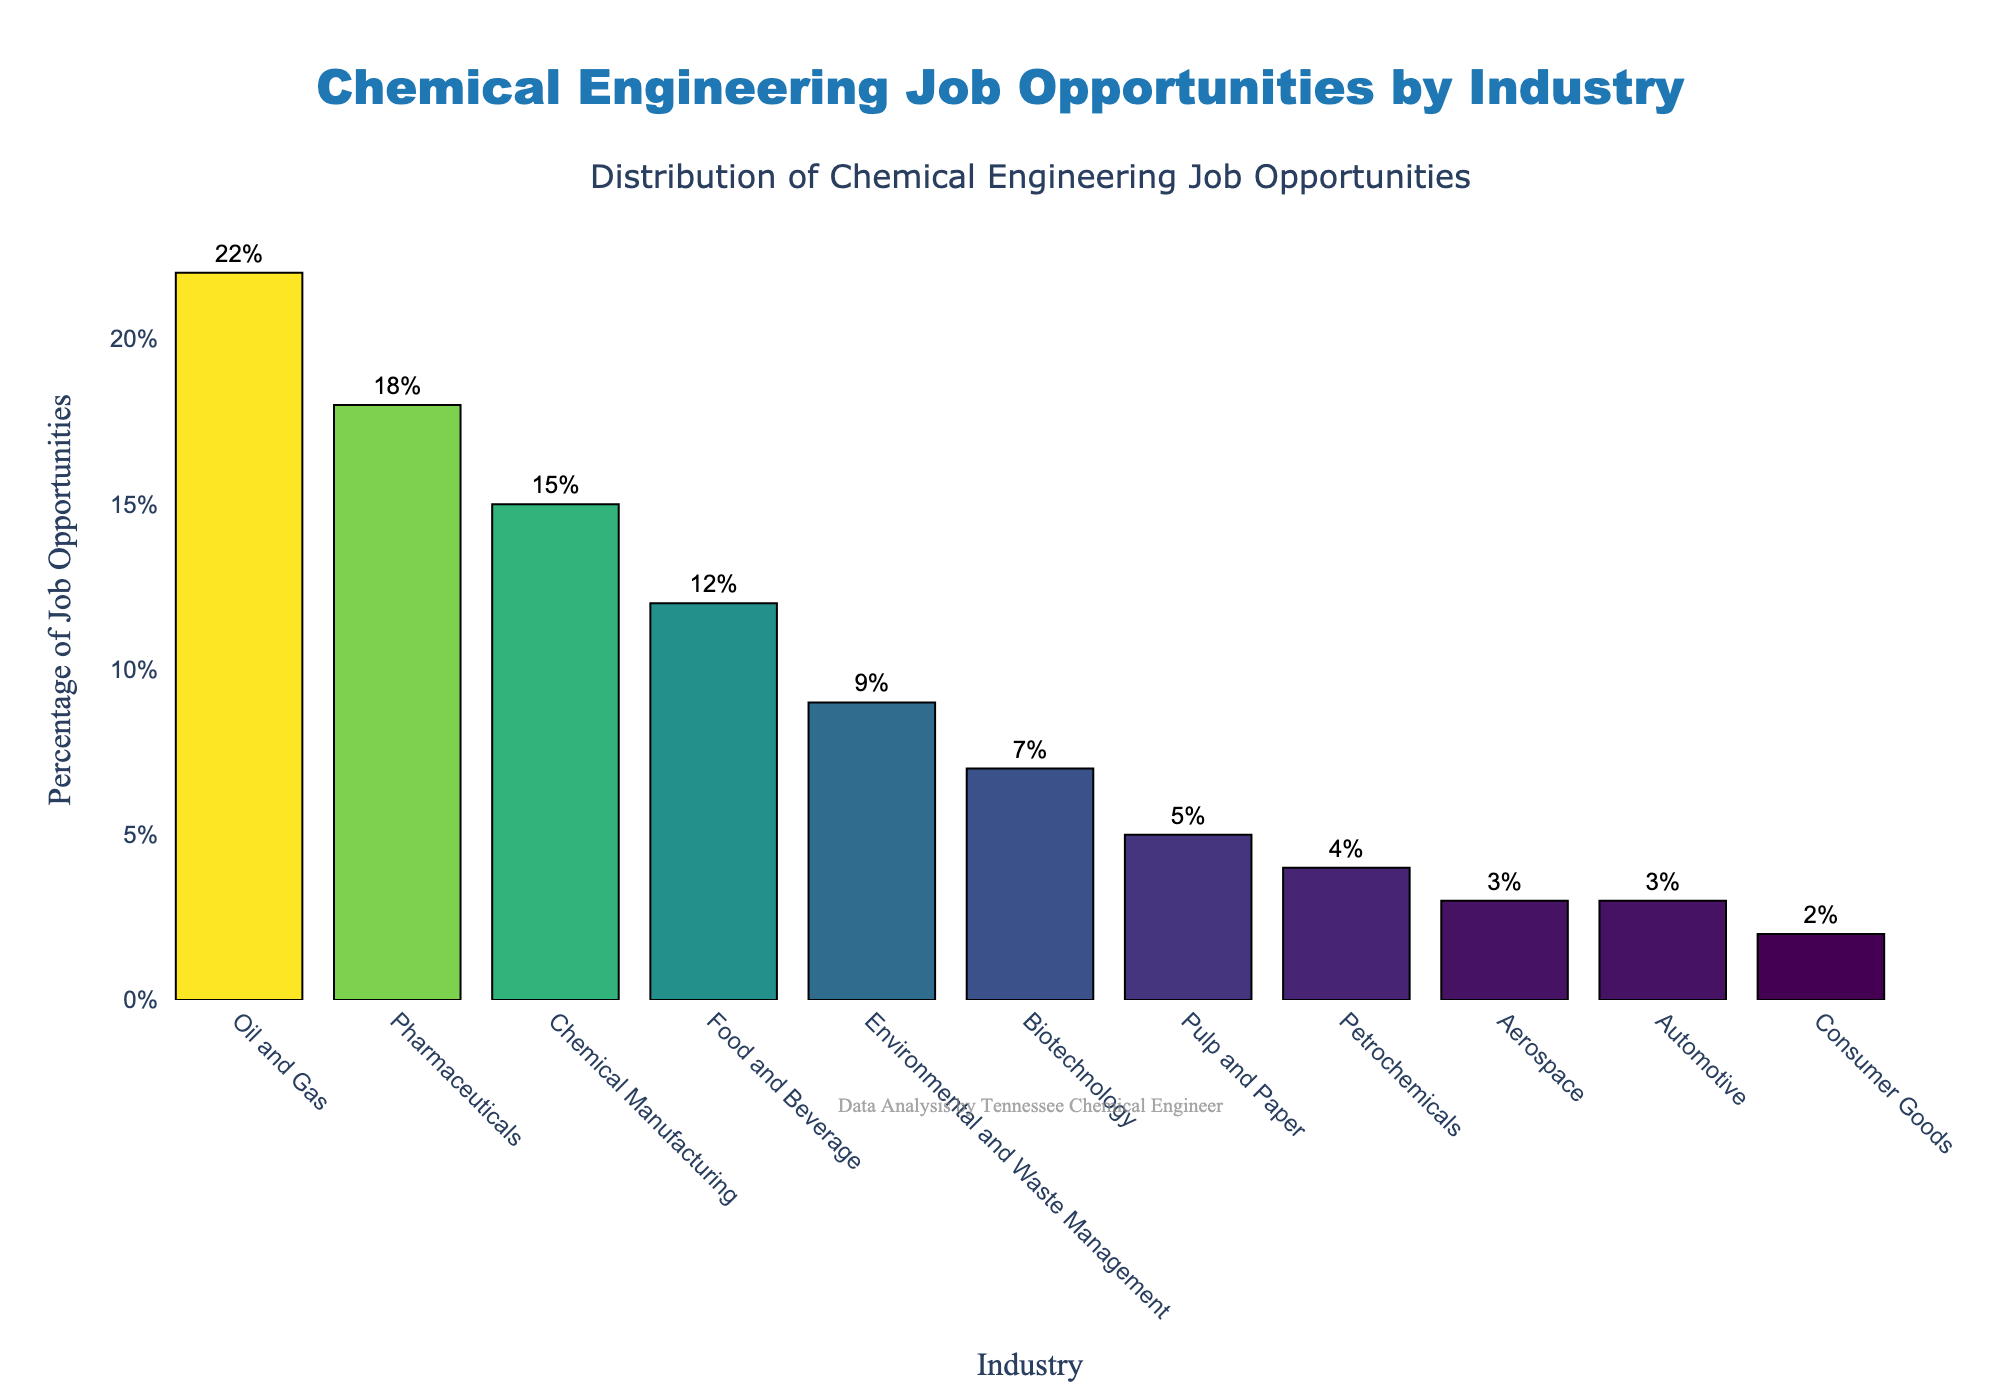what's the percentage of job opportunities in the pharmaceutical industry? To find the percentage, look at the bar labeled "Pharmaceuticals" on the x-axis. The height of the bar, as indicated by the text, represents 18%.
Answer: 18% which industry has the smallest percentage of chemical engineering job opportunities? To determine the industry with the smallest percentage, look for the shortest bar in the chart. The shortest bar corresponds to the "Consumer Goods" industry, which has a value of 2%.
Answer: Consumer Goods how much higher is the percentage of job opportunities in the oil and gas industry compared to the biotechnology industry? First, find the percentages for both industries: Oil and Gas is 22% and Biotechnology is 7%. Then, subtract Biotechnology's percentage from Oil and Gas's percentage: 22% - 7% = 15%.
Answer: 15% what's the total percentage of job opportunities in the top three industries? Add the percentages of the top three industries: Oil and Gas (22%), Pharmaceuticals (18%), and Chemical Manufacturing (15%): 22% + 18% + 15% = 55%.
Answer: 55% which industries have job opportunities percentages within 2% of each other, and what are these percentages? Look for industries with bars close in height. "Automotive" and "Aerospace" both have percentages of 3%, indicating they are equal and within 0% of each other.
Answer: Automotive and Aerospace (3%) what's the combined percentage of job opportunities in the food and beverage and chemical manufacturing industries? Add the percentages for the Food and Beverage (12%) and Chemical Manufacturing (15%) industries: 12% + 15% = 27%.
Answer: 27% how many industries have a job opportunities percentage less than 10%? Count the number of bars that are below the 10% line: Environmental and Waste Management (9%), Biotechnology (7%), Pulp and Paper (5%), Petrochemicals (4%), Aerospace (3%), Automotive (3%), and Consumer Goods (2%). There are 7 industries.
Answer: 7 which industry has the second highest percentage of job opportunities? The second highest bar after Oil and Gas (22%) is Pharmaceuticals at 18%. Confirm by checking the height and value text of the respective bars.
Answer: Pharmaceuticals 